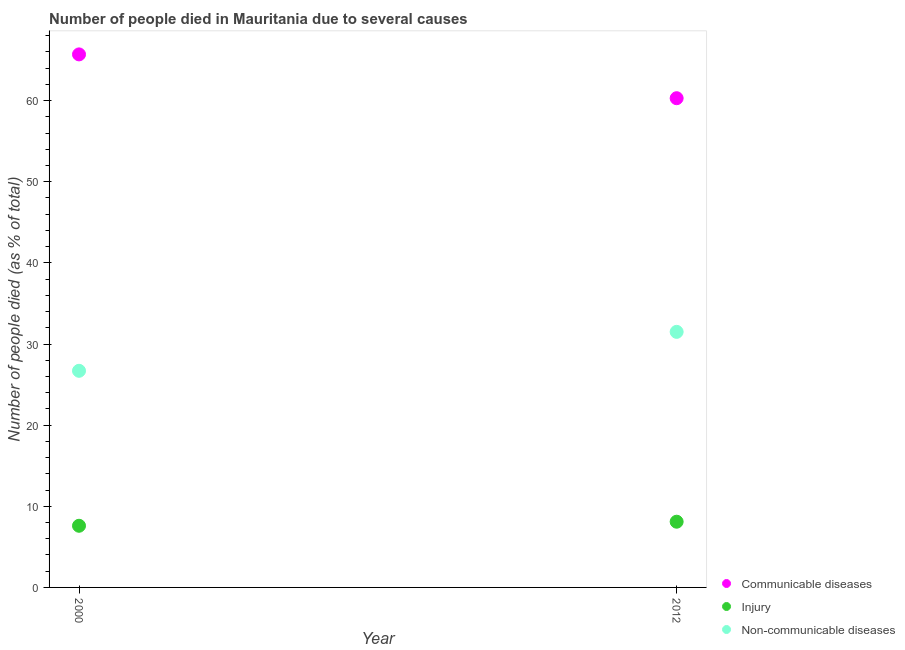What is the number of people who dies of non-communicable diseases in 2012?
Offer a very short reply. 31.5. Across all years, what is the maximum number of people who died of communicable diseases?
Offer a terse response. 65.7. In which year was the number of people who dies of non-communicable diseases maximum?
Make the answer very short. 2012. What is the total number of people who died of communicable diseases in the graph?
Keep it short and to the point. 126. What is the difference between the number of people who dies of non-communicable diseases in 2012 and the number of people who died of communicable diseases in 2000?
Keep it short and to the point. -34.2. What is the average number of people who died of injury per year?
Your answer should be very brief. 7.85. In the year 2000, what is the difference between the number of people who dies of non-communicable diseases and number of people who died of communicable diseases?
Your response must be concise. -39. In how many years, is the number of people who died of communicable diseases greater than 38 %?
Your answer should be very brief. 2. What is the ratio of the number of people who dies of non-communicable diseases in 2000 to that in 2012?
Keep it short and to the point. 0.85. Is it the case that in every year, the sum of the number of people who died of communicable diseases and number of people who died of injury is greater than the number of people who dies of non-communicable diseases?
Provide a short and direct response. Yes. How many dotlines are there?
Give a very brief answer. 3. What is the difference between two consecutive major ticks on the Y-axis?
Keep it short and to the point. 10. Does the graph contain grids?
Provide a short and direct response. No. How are the legend labels stacked?
Your answer should be very brief. Vertical. What is the title of the graph?
Your response must be concise. Number of people died in Mauritania due to several causes. What is the label or title of the Y-axis?
Make the answer very short. Number of people died (as % of total). What is the Number of people died (as % of total) of Communicable diseases in 2000?
Give a very brief answer. 65.7. What is the Number of people died (as % of total) of Injury in 2000?
Make the answer very short. 7.6. What is the Number of people died (as % of total) of Non-communicable diseases in 2000?
Give a very brief answer. 26.7. What is the Number of people died (as % of total) of Communicable diseases in 2012?
Keep it short and to the point. 60.3. What is the Number of people died (as % of total) of Non-communicable diseases in 2012?
Your answer should be very brief. 31.5. Across all years, what is the maximum Number of people died (as % of total) in Communicable diseases?
Give a very brief answer. 65.7. Across all years, what is the maximum Number of people died (as % of total) of Injury?
Provide a succinct answer. 8.1. Across all years, what is the maximum Number of people died (as % of total) of Non-communicable diseases?
Your answer should be compact. 31.5. Across all years, what is the minimum Number of people died (as % of total) of Communicable diseases?
Your answer should be very brief. 60.3. Across all years, what is the minimum Number of people died (as % of total) in Non-communicable diseases?
Your response must be concise. 26.7. What is the total Number of people died (as % of total) of Communicable diseases in the graph?
Your answer should be very brief. 126. What is the total Number of people died (as % of total) in Non-communicable diseases in the graph?
Offer a very short reply. 58.2. What is the difference between the Number of people died (as % of total) in Communicable diseases in 2000 and that in 2012?
Provide a short and direct response. 5.4. What is the difference between the Number of people died (as % of total) of Non-communicable diseases in 2000 and that in 2012?
Make the answer very short. -4.8. What is the difference between the Number of people died (as % of total) of Communicable diseases in 2000 and the Number of people died (as % of total) of Injury in 2012?
Your response must be concise. 57.6. What is the difference between the Number of people died (as % of total) in Communicable diseases in 2000 and the Number of people died (as % of total) in Non-communicable diseases in 2012?
Provide a short and direct response. 34.2. What is the difference between the Number of people died (as % of total) of Injury in 2000 and the Number of people died (as % of total) of Non-communicable diseases in 2012?
Offer a very short reply. -23.9. What is the average Number of people died (as % of total) of Injury per year?
Make the answer very short. 7.85. What is the average Number of people died (as % of total) in Non-communicable diseases per year?
Provide a succinct answer. 29.1. In the year 2000, what is the difference between the Number of people died (as % of total) in Communicable diseases and Number of people died (as % of total) in Injury?
Your answer should be very brief. 58.1. In the year 2000, what is the difference between the Number of people died (as % of total) in Communicable diseases and Number of people died (as % of total) in Non-communicable diseases?
Offer a very short reply. 39. In the year 2000, what is the difference between the Number of people died (as % of total) in Injury and Number of people died (as % of total) in Non-communicable diseases?
Provide a short and direct response. -19.1. In the year 2012, what is the difference between the Number of people died (as % of total) in Communicable diseases and Number of people died (as % of total) in Injury?
Your answer should be very brief. 52.2. In the year 2012, what is the difference between the Number of people died (as % of total) in Communicable diseases and Number of people died (as % of total) in Non-communicable diseases?
Make the answer very short. 28.8. In the year 2012, what is the difference between the Number of people died (as % of total) of Injury and Number of people died (as % of total) of Non-communicable diseases?
Keep it short and to the point. -23.4. What is the ratio of the Number of people died (as % of total) in Communicable diseases in 2000 to that in 2012?
Provide a succinct answer. 1.09. What is the ratio of the Number of people died (as % of total) of Injury in 2000 to that in 2012?
Offer a very short reply. 0.94. What is the ratio of the Number of people died (as % of total) of Non-communicable diseases in 2000 to that in 2012?
Your answer should be very brief. 0.85. What is the difference between the highest and the lowest Number of people died (as % of total) of Non-communicable diseases?
Your response must be concise. 4.8. 